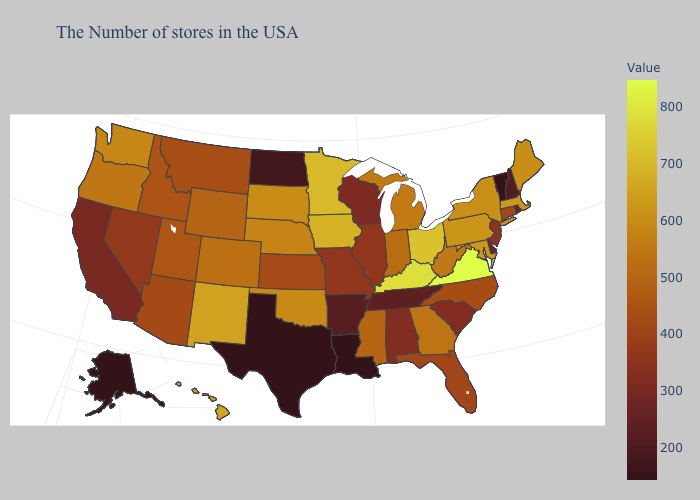Among the states that border Michigan , which have the highest value?
Short answer required. Ohio. Which states have the lowest value in the West?
Write a very short answer. Alaska. Which states hav the highest value in the Northeast?
Give a very brief answer. Massachusetts. Among the states that border Montana , does Wyoming have the lowest value?
Be succinct. No. Among the states that border New Mexico , does Oklahoma have the highest value?
Answer briefly. Yes. Which states have the lowest value in the MidWest?
Answer briefly. North Dakota. Does Vermont have the lowest value in the USA?
Short answer required. Yes. Does the map have missing data?
Be succinct. No. 